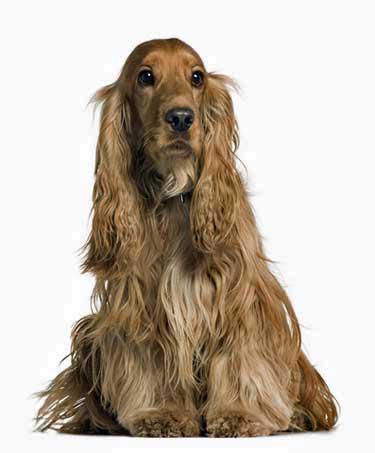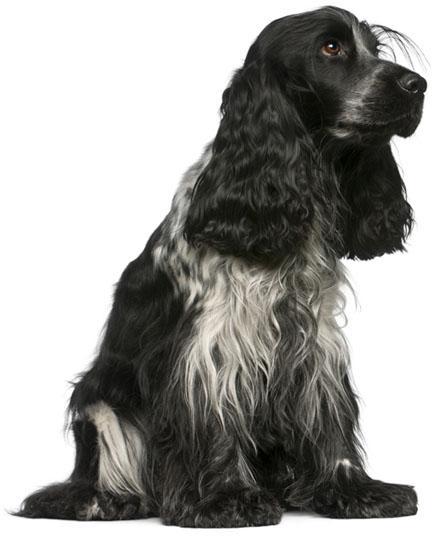The first image is the image on the left, the second image is the image on the right. Examine the images to the left and right. Is the description "There are at least three dogs in total." accurate? Answer yes or no. No. 